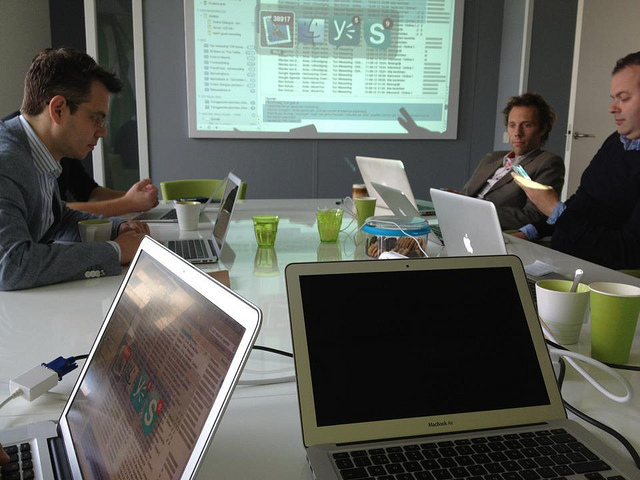Read and extract the text from this image. S Y S 